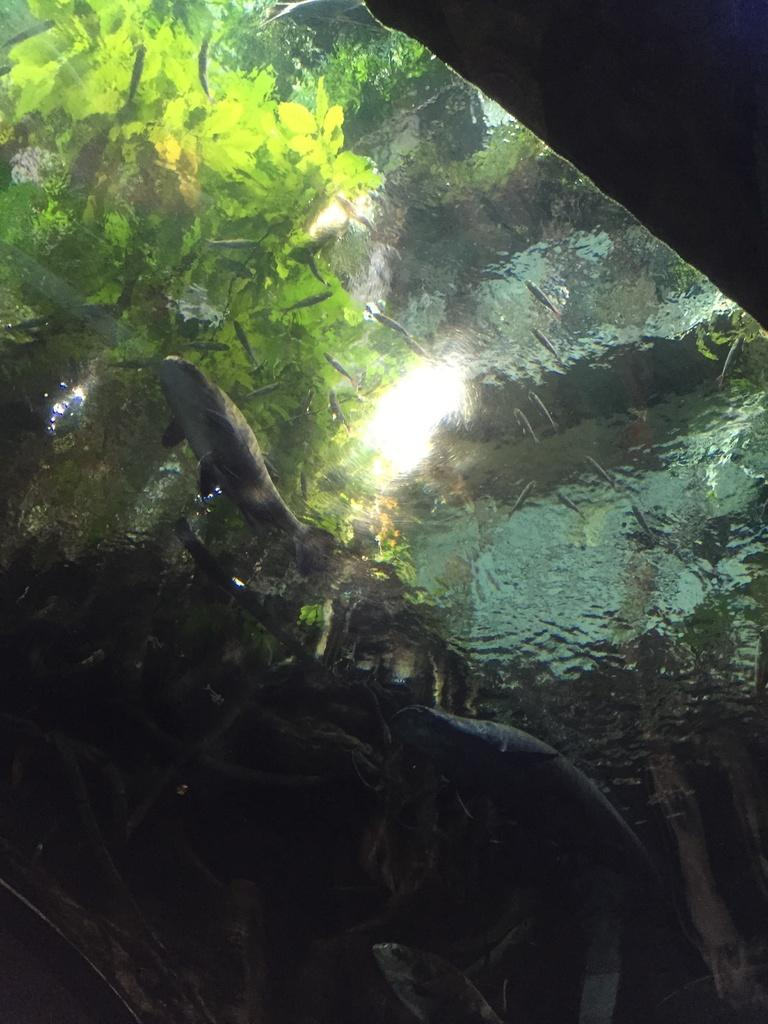What is moving in the water in the image? There are fishes moving in the water in the image. What can be seen in the water besides the fishes? The reflection of a tree is visible in the image. How many pies are being served in the image? There are no pies present in the image; it features fishes moving in the water and the reflection of a tree. What shape is the good-bye being formed in the image? There is no good-bye or circle present in the image. 